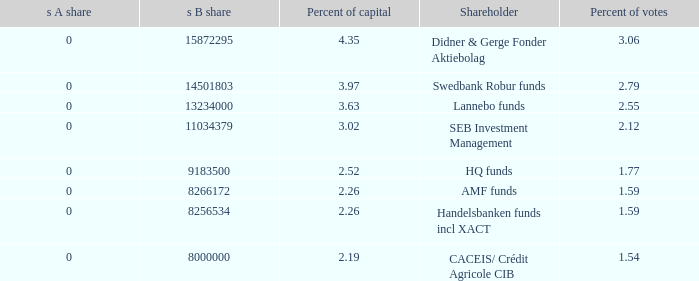What is the s B share for the shareholder that has 2.12 percent of votes?  11034379.0. 